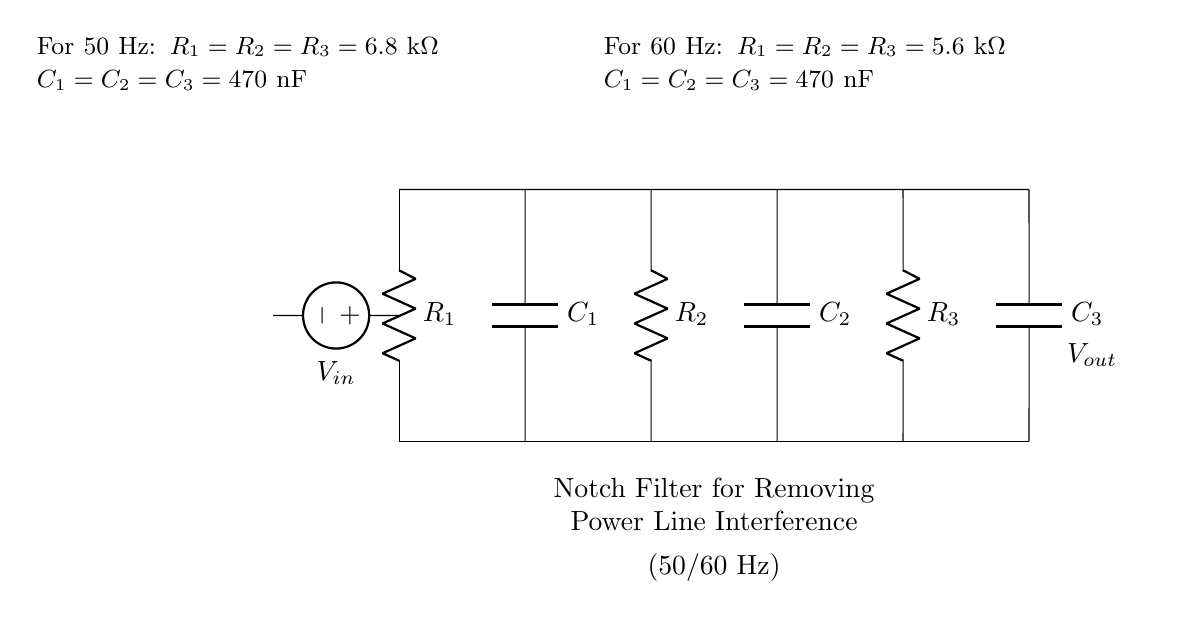What is the type of filter represented in the circuit? The circuit is categorized as a notch filter, which is designed to attenuate specific frequency components, particularly power line interference.
Answer: Notch filter What is the voltage source symbol used in the circuit? The diagram depicts an American voltage source, represented by the symbol with a positive and negative terminal, indicating the input voltage.
Answer: American voltage source How many resistors are present in the circuit? The circuit includes three resistors, identified by the labels on each resistor in the diagram.
Answer: Three What are the capacitance values for the capacitors in this circuit for 50 Hz operation? For the 50 Hz configuration, all capacitors (C1, C2, C3) are specified to have a capacitance of 470 nanofarads, as noted in the labeling.
Answer: 470 nanofarads What is the resistance value for the resistors when used for 60 Hz? The resistance value for the resistors (R1, R2, R3) in the 60 Hz configuration is indicated as 5.6 kilo ohms, as per the provided information in the diagram.
Answer: 5.6 kilo ohms What is the effect of this notch filter on the 50 Hz power line interference? The notch filter is engineered to significantly reduce or eliminate unwanted noise at the specific frequency of 50 Hz, effectively improving signal quality.
Answer: Reduce noise Which components work together to tuned to the power line frequency? The combination of resistors and capacitors (R1, R2, R3 and C1, C2, C3) together form a resonant circuit that is specifically tuned to the power line frequency, enabling effective filtering.
Answer: Resistors and capacitors 